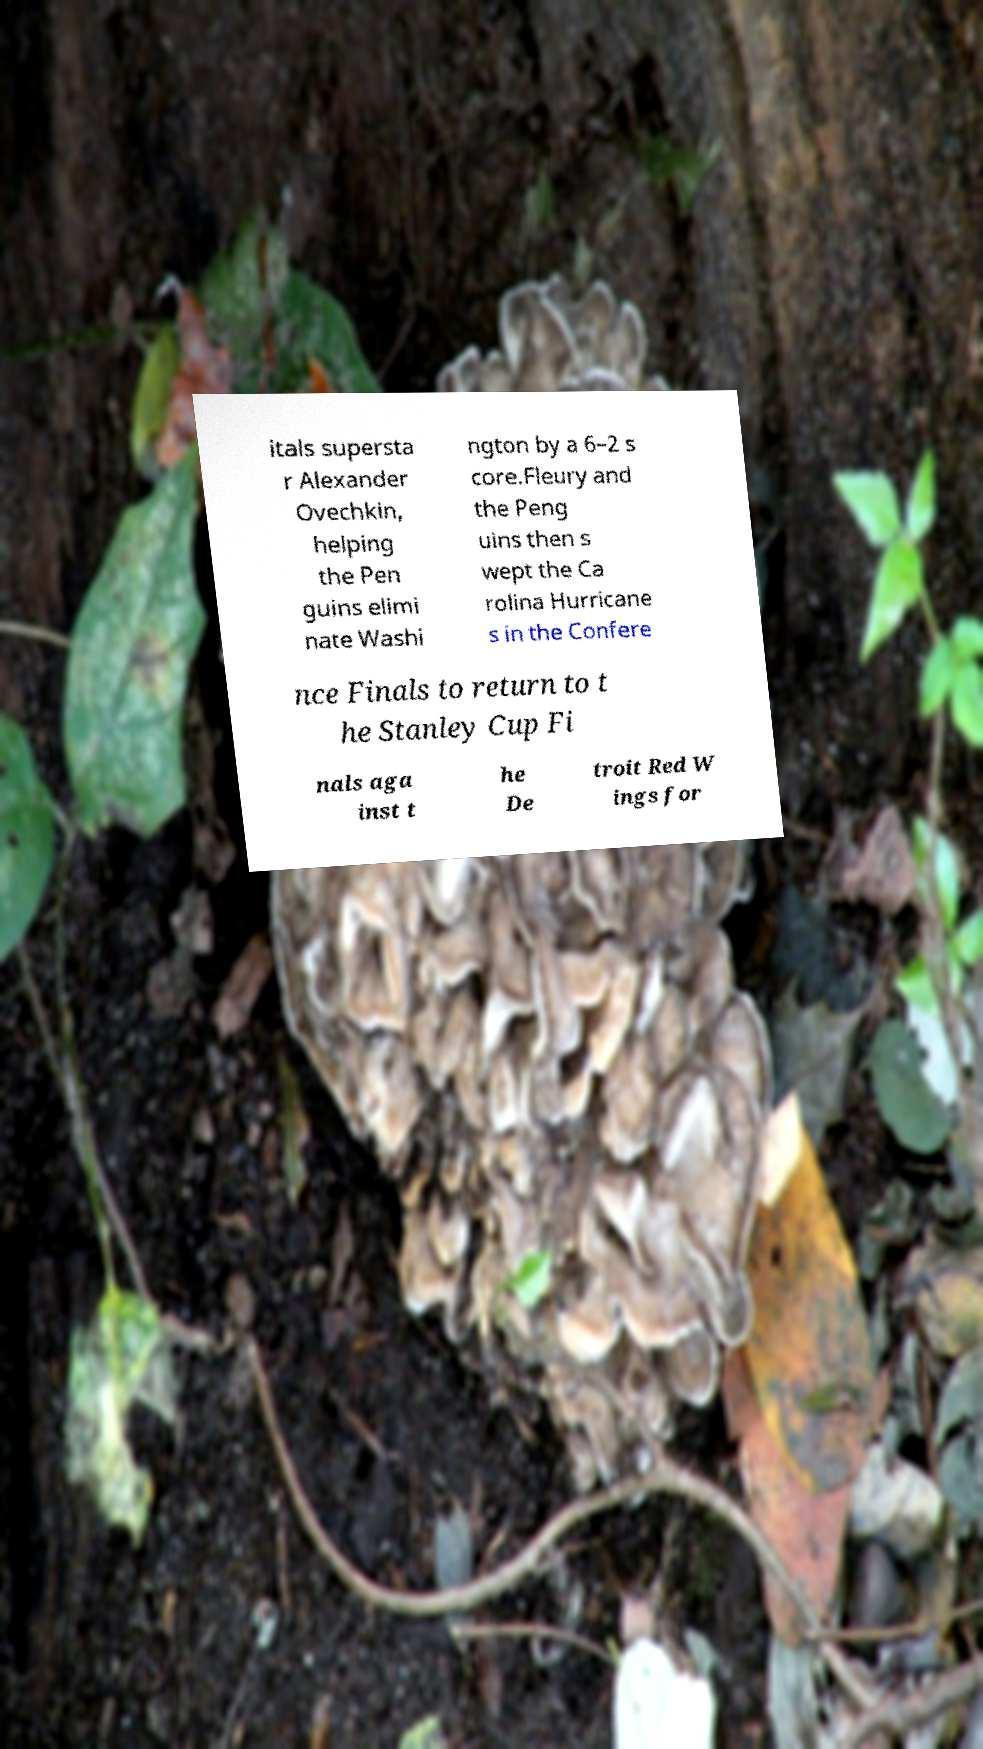What messages or text are displayed in this image? I need them in a readable, typed format. itals supersta r Alexander Ovechkin, helping the Pen guins elimi nate Washi ngton by a 6–2 s core.Fleury and the Peng uins then s wept the Ca rolina Hurricane s in the Confere nce Finals to return to t he Stanley Cup Fi nals aga inst t he De troit Red W ings for 